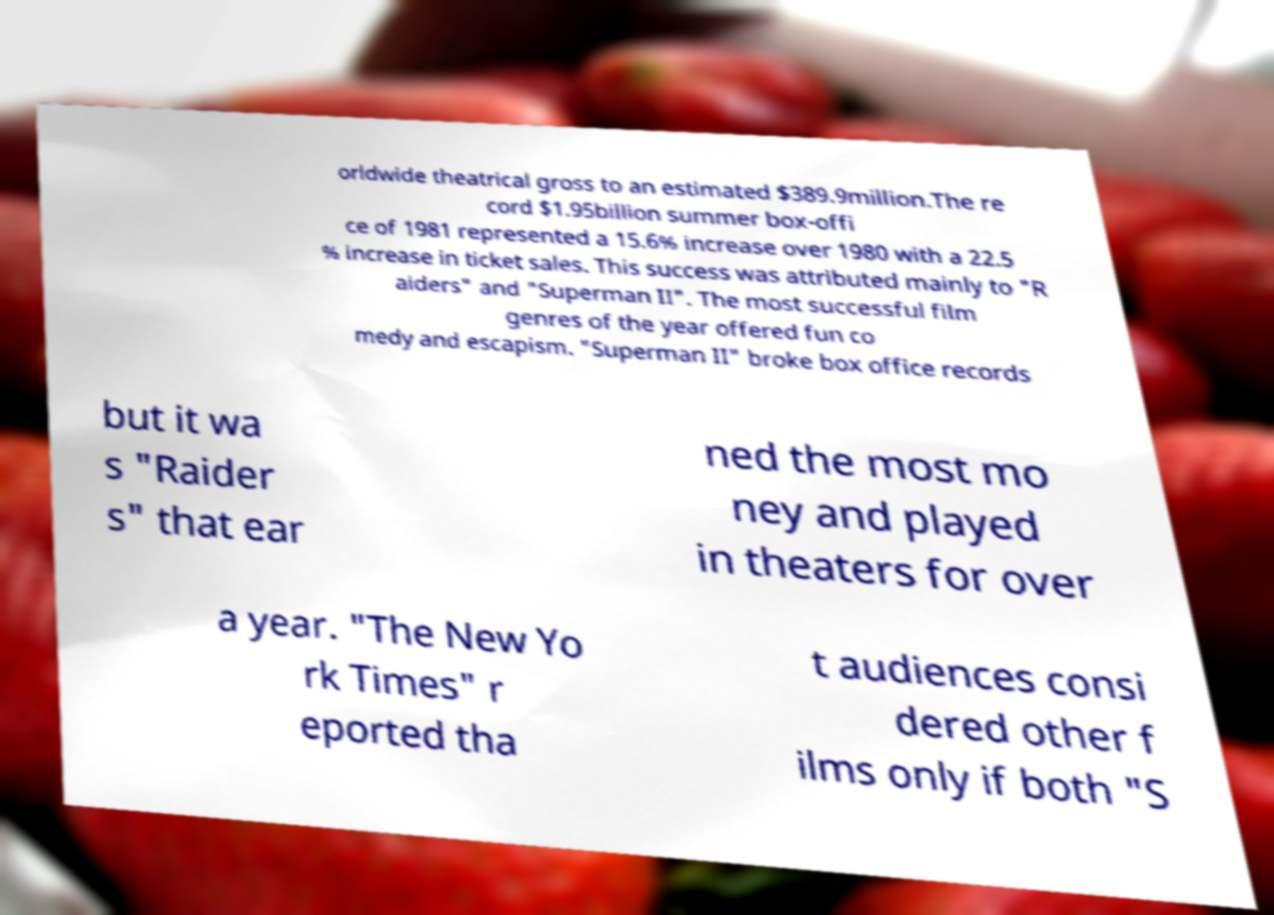Can you read and provide the text displayed in the image?This photo seems to have some interesting text. Can you extract and type it out for me? orldwide theatrical gross to an estimated $389.9million.The re cord $1.95billion summer box-offi ce of 1981 represented a 15.6% increase over 1980 with a 22.5 % increase in ticket sales. This success was attributed mainly to "R aiders" and "Superman II". The most successful film genres of the year offered fun co medy and escapism. "Superman II" broke box office records but it wa s "Raider s" that ear ned the most mo ney and played in theaters for over a year. "The New Yo rk Times" r eported tha t audiences consi dered other f ilms only if both "S 